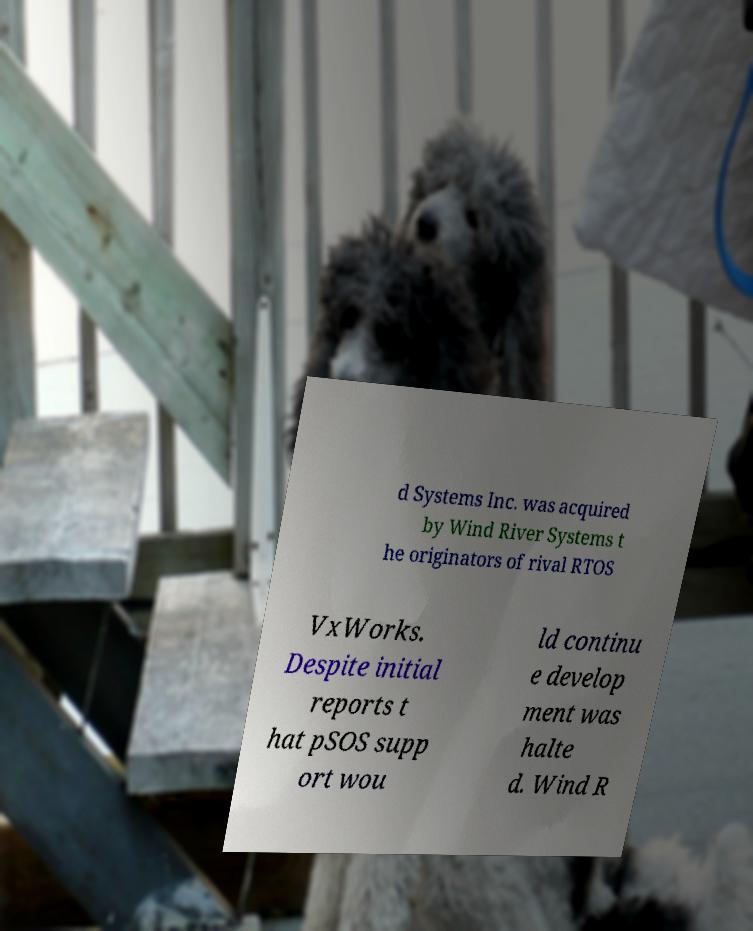What messages or text are displayed in this image? I need them in a readable, typed format. d Systems Inc. was acquired by Wind River Systems t he originators of rival RTOS VxWorks. Despite initial reports t hat pSOS supp ort wou ld continu e develop ment was halte d. Wind R 